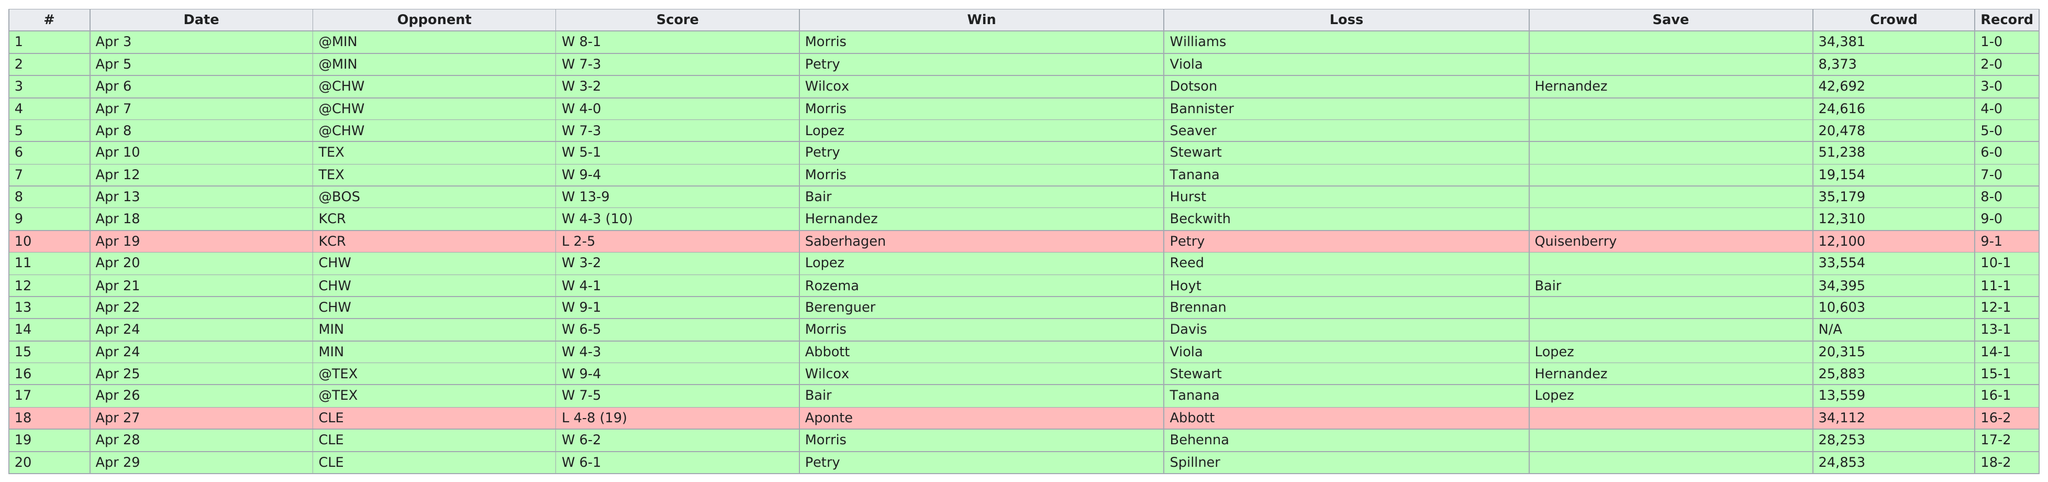Outline some significant characteristics in this image. In April, there was a game that the team did not win. After playing 9 games, they finally lost. Morris won the competition 5 times. The combined number of times Player 1 and Player 2 have played against each other, with Player 1 having a Minion card with the ability to draw an extra card whenever the current Player's turn ends, is 2. There were times when the score was 9-1. 